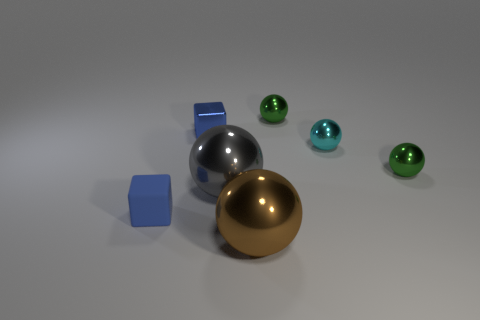Subtract all cyan spheres. How many spheres are left? 4 Subtract all blue spheres. Subtract all purple cylinders. How many spheres are left? 5 Add 2 tiny green metallic spheres. How many objects exist? 9 Subtract all cubes. How many objects are left? 5 Subtract 0 gray cylinders. How many objects are left? 7 Subtract all small blue cubes. Subtract all large gray spheres. How many objects are left? 4 Add 6 small rubber cubes. How many small rubber cubes are left? 7 Add 1 blue rubber things. How many blue rubber things exist? 2 